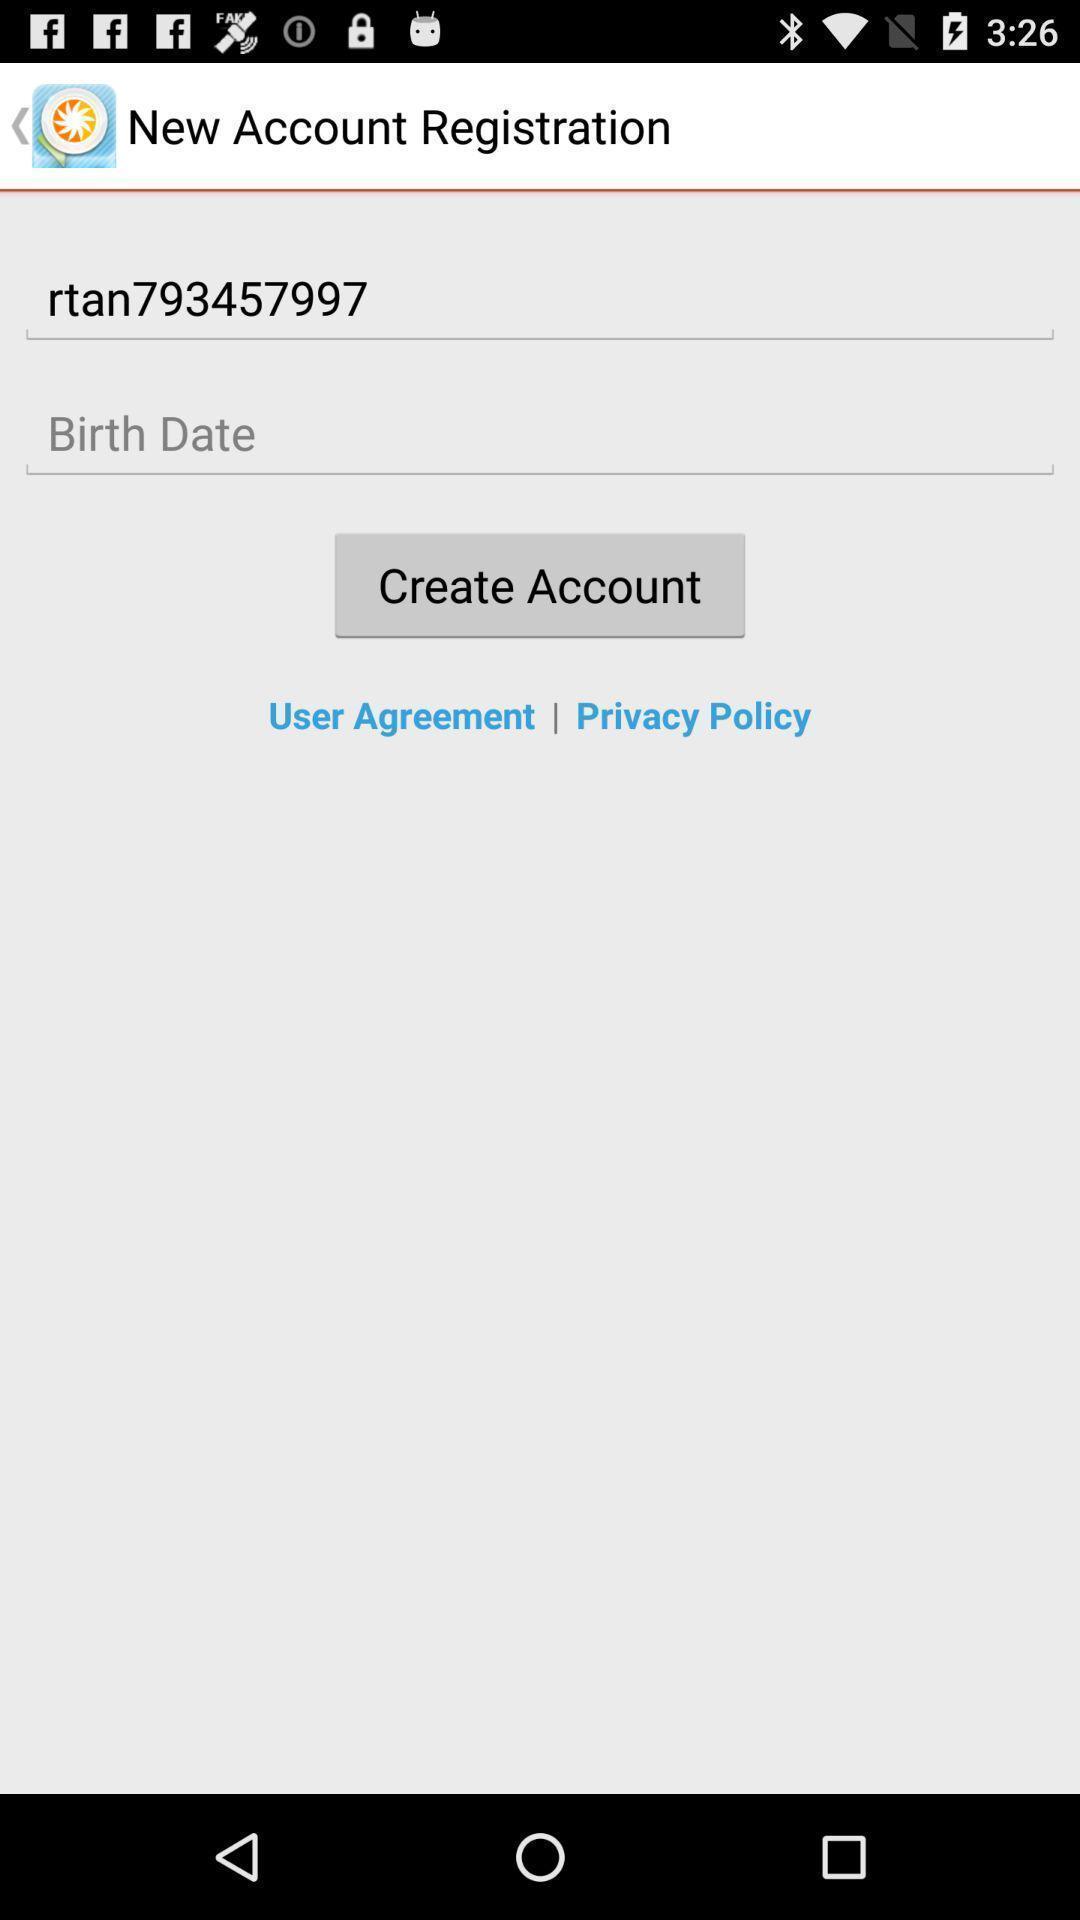Provide a detailed account of this screenshot. Registration page. 